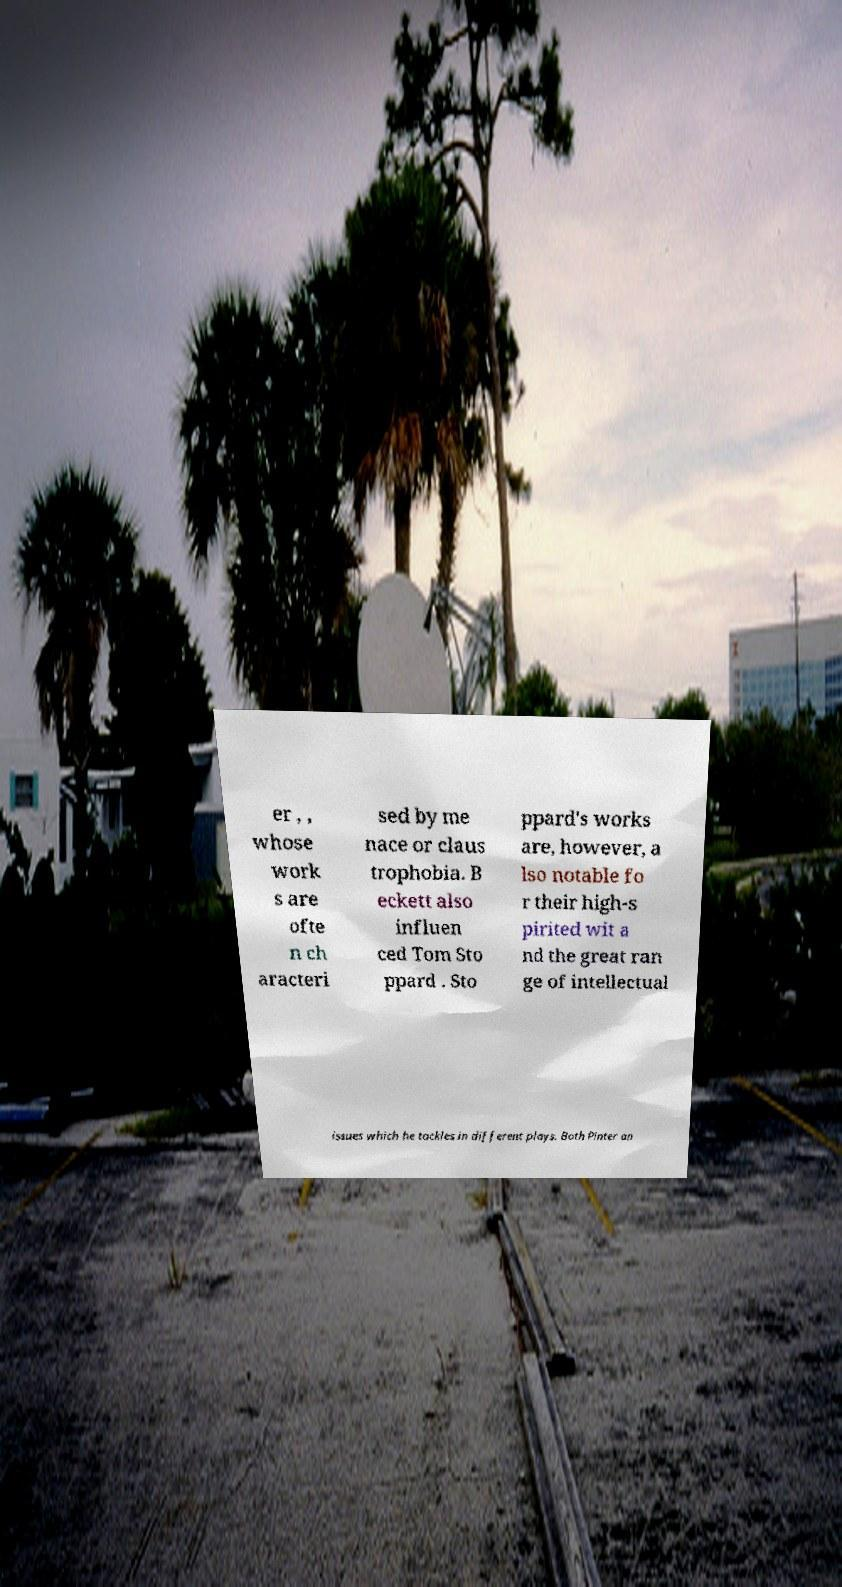Can you read and provide the text displayed in the image?This photo seems to have some interesting text. Can you extract and type it out for me? er , , whose work s are ofte n ch aracteri sed by me nace or claus trophobia. B eckett also influen ced Tom Sto ppard . Sto ppard's works are, however, a lso notable fo r their high-s pirited wit a nd the great ran ge of intellectual issues which he tackles in different plays. Both Pinter an 